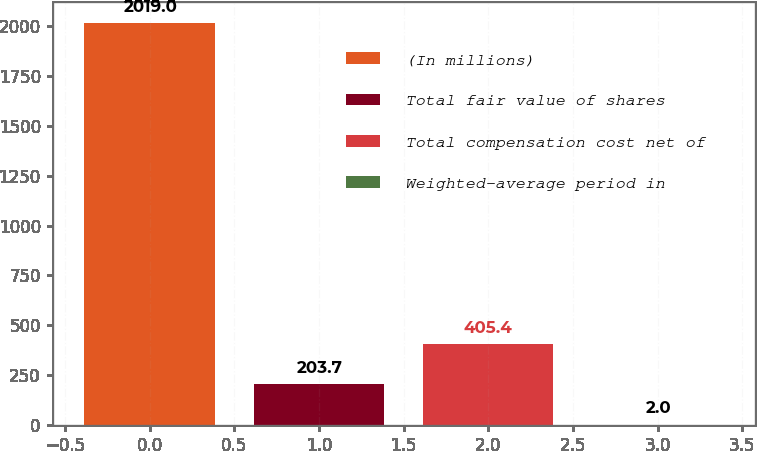<chart> <loc_0><loc_0><loc_500><loc_500><bar_chart><fcel>(In millions)<fcel>Total fair value of shares<fcel>Total compensation cost net of<fcel>Weighted-average period in<nl><fcel>2019<fcel>203.7<fcel>405.4<fcel>2<nl></chart> 